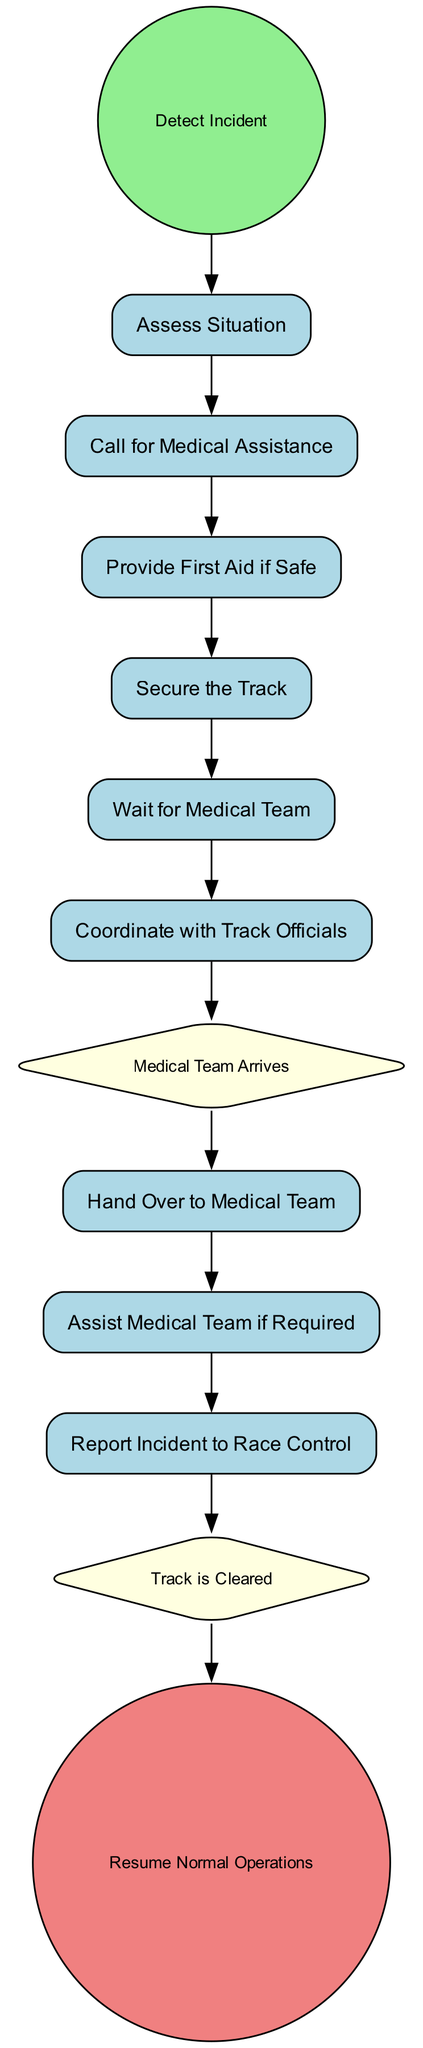What is the first step in the emergency response procedure? The procedure starts with the "Detect Incident" node, indicating that identifying an incident is the initial action required in the response process.
Answer: Detect Incident How many activities are there in the diagram? By examining the nodes in the diagram, I can see that there are a total of six activities: "Assess Situation," "Call for Medical Assistance," "Provide First Aid if Safe," "Secure the Track," "Wait for Medical Team," and "Coordinate with Track Officials."
Answer: Six Which node follows "Call for Medical Assistance"? The flow of the diagram shows that the node that immediately follows "Call for Medical Assistance" is "Provide First Aid if Safe." This indicates that after calling for help, the next action is to offer first aid, if it is safe to do so.
Answer: Provide First Aid if Safe What is the final event of the emergency response procedure? The end of the procedure concludes with the "Resume Normal Operations" node, which signifies that normal activities can recommence once all necessary actions in response to the incident have been completed.
Answer: Resume Normal Operations What is the relationship between "Wait for Medical Team" and "Medical Team Arrives"? The diagram illustrates that the "Wait for Medical Team" activity leads to the "Medical Team Arrives" intermediate event, showing that waiting for the medical team is a prerequisite for their arrival.
Answer: Leads to What happens after the "Hand Over to Medical Team"? After the "Hand Over to Medical Team" activity, the flow continues to "Assist Medical Team if Required," indicating that there may be further involvement needed from the person ensuring that the medical team has everything they need.
Answer: Assist Medical Team if Required What type of event is "Track is Cleared"? The node "Track is Cleared" is classified as an intermediate event, which usually represents a transition point within the procedure that signifies a specific condition has been achieved in the flow.
Answer: Intermediate Event How many intermediate events are present in the diagram? There are two intermediate events within the diagram: "Medical Team Arrives" and "Track is Cleared." This indicates key moments where the procedure transitions to the next stage.
Answer: Two What action should be taken after the "Assess Situation"? The activity that follows "Assess Situation" is "Call for Medical Assistance," indicating that the next step, once the situation is understood, is to seek help from medical services.
Answer: Call for Medical Assistance 